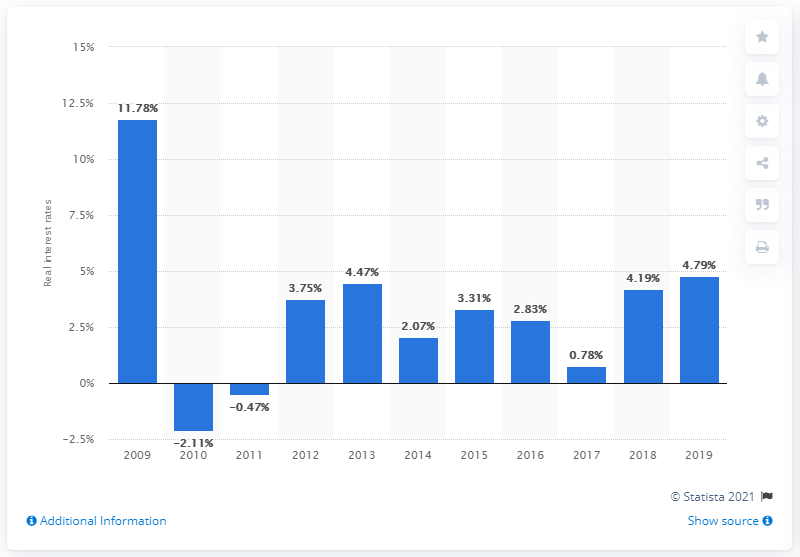Draw attention to some important aspects in this diagram. In 2019, the deposit interest rate in Malaysia was 4.79%. The previous year's deposit interest rate in Malaysia was 4.19%. 